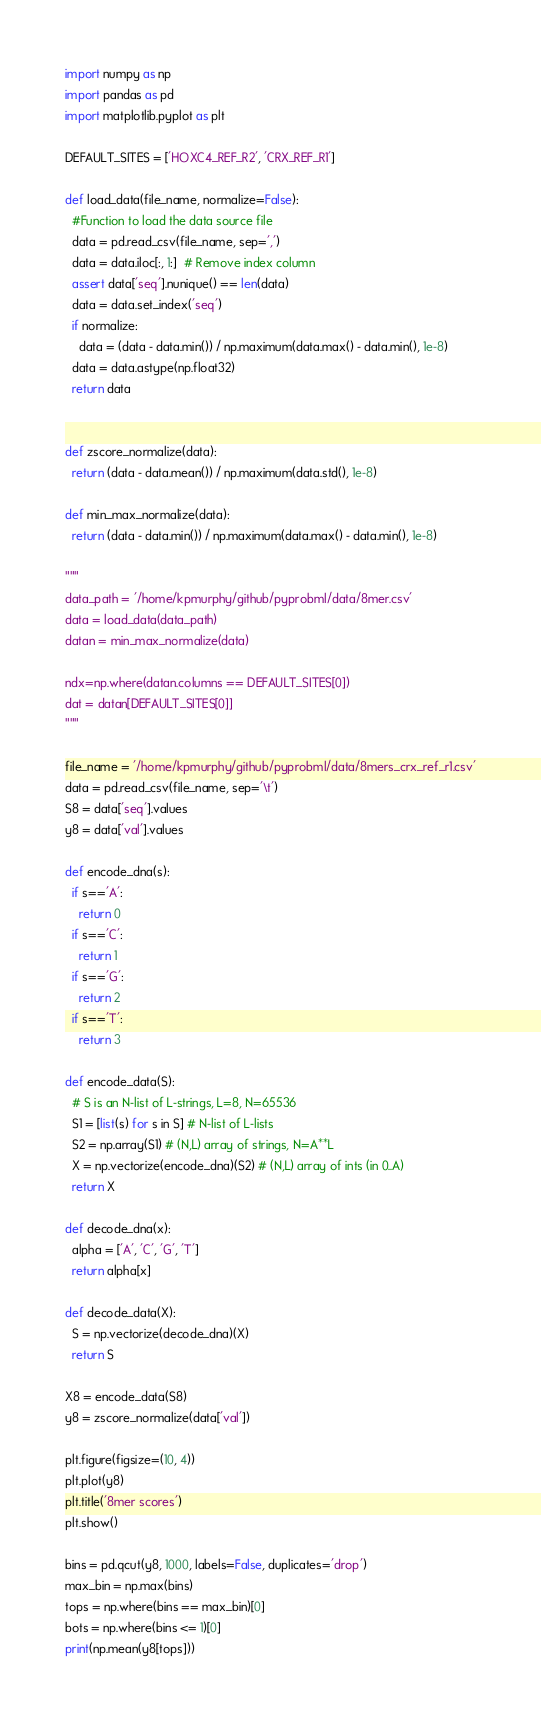Convert code to text. <code><loc_0><loc_0><loc_500><loc_500><_Python_>import numpy as np
import pandas as pd
import matplotlib.pyplot as plt

DEFAULT_SITES = ['HOXC4_REF_R2', 'CRX_REF_R1']

def load_data(file_name, normalize=False):
  #Function to load the data source file 
  data = pd.read_csv(file_name, sep=',')
  data = data.iloc[:, 1:]  # Remove index column
  assert data['seq'].nunique() == len(data)
  data = data.set_index('seq')
  if normalize:
    data = (data - data.min()) / np.maximum(data.max() - data.min(), 1e-8)
  data = data.astype(np.float32)
  return data


def zscore_normalize(data):
  return (data - data.mean()) / np.maximum(data.std(), 1e-8)

def min_max_normalize(data):
  return (data - data.min()) / np.maximum(data.max() - data.min(), 1e-8)

"""
data_path = '/home/kpmurphy/github/pyprobml/data/8mer.csv'
data = load_data(data_path)
datan = min_max_normalize(data)

ndx=np.where(datan.columns == DEFAULT_SITES[0])
dat = datan[DEFAULT_SITES[0]]
"""

file_name = '/home/kpmurphy/github/pyprobml/data/8mers_crx_ref_r1.csv'
data = pd.read_csv(file_name, sep='\t')
S8 = data['seq'].values
y8 = data['val'].values

def encode_dna(s):
  if s=='A':
    return 0
  if s=='C':
    return 1
  if s=='G':
    return 2
  if s=='T':
    return 3
  
def encode_data(S):
  # S is an N-list of L-strings, L=8, N=65536
  S1 = [list(s) for s in S] # N-list of L-lists
  S2 = np.array(S1) # (N,L) array of strings, N=A**L
  X = np.vectorize(encode_dna)(S2) # (N,L) array of ints (in 0..A)
  return X

def decode_dna(x):
  alpha = ['A', 'C', 'G', 'T']
  return alpha[x]

def decode_data(X):
  S = np.vectorize(decode_dna)(X)
  return S

X8 = encode_data(S8)
y8 = zscore_normalize(data['val'])

plt.figure(figsize=(10, 4))
plt.plot(y8)
plt.title('8mer scores')
plt.show()

bins = pd.qcut(y8, 1000, labels=False, duplicates='drop')
max_bin = np.max(bins)
tops = np.where(bins == max_bin)[0]
bots = np.where(bins <= 1)[0]
print(np.mean(y8[tops]))
</code> 